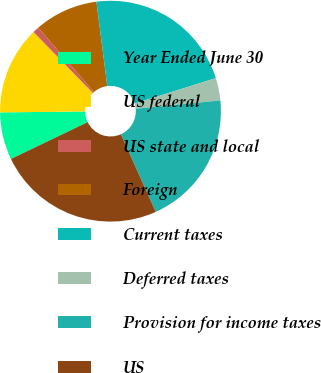Convert chart to OTSL. <chart><loc_0><loc_0><loc_500><loc_500><pie_chart><fcel>Year Ended June 30<fcel>US federal<fcel>US state and local<fcel>Foreign<fcel>Current taxes<fcel>Deferred taxes<fcel>Provision for income taxes<fcel>US<nl><fcel>6.95%<fcel>12.9%<fcel>0.92%<fcel>9.32%<fcel>22.2%<fcel>3.29%<fcel>19.83%<fcel>24.6%<nl></chart> 